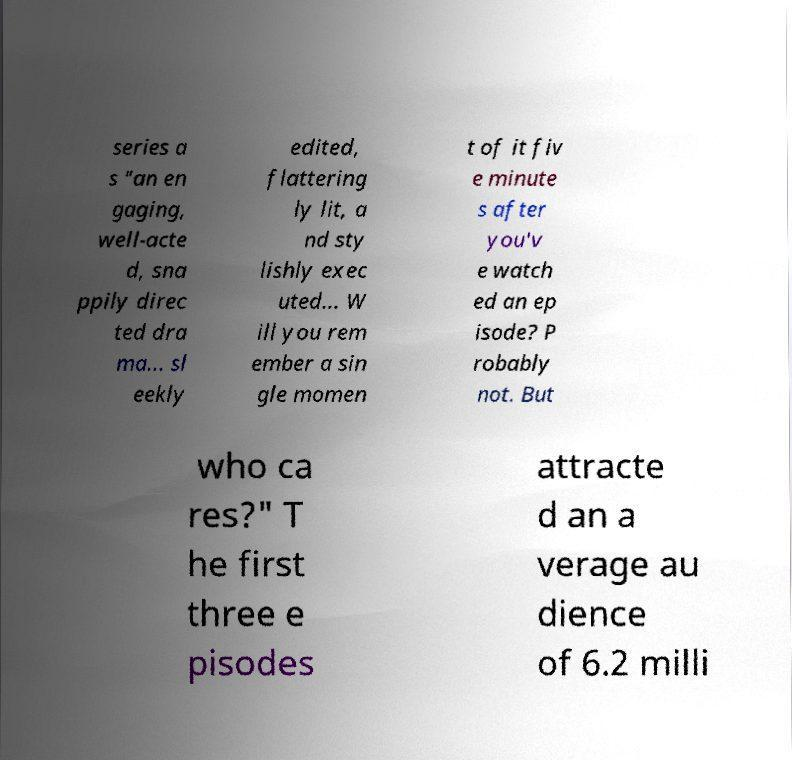Could you extract and type out the text from this image? series a s "an en gaging, well-acte d, sna ppily direc ted dra ma... sl eekly edited, flattering ly lit, a nd sty lishly exec uted... W ill you rem ember a sin gle momen t of it fiv e minute s after you'v e watch ed an ep isode? P robably not. But who ca res?" T he first three e pisodes attracte d an a verage au dience of 6.2 milli 